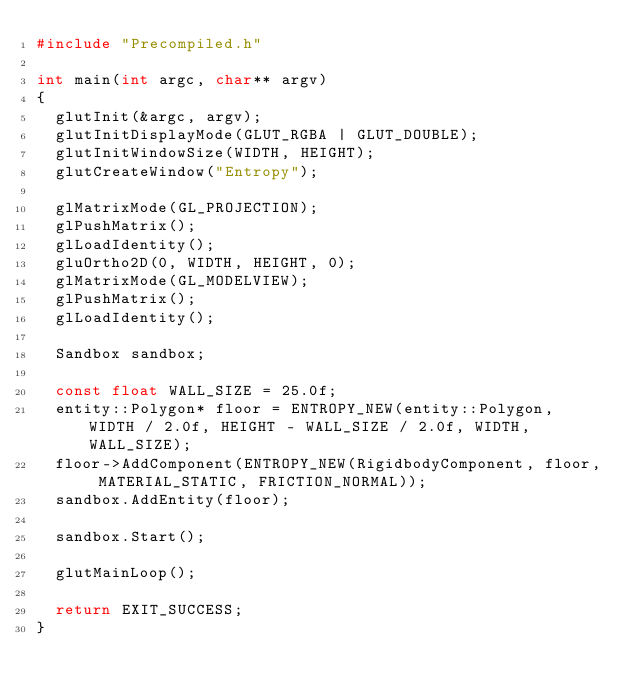Convert code to text. <code><loc_0><loc_0><loc_500><loc_500><_C++_>#include "Precompiled.h"

int main(int argc, char** argv)
{
	glutInit(&argc, argv);
	glutInitDisplayMode(GLUT_RGBA | GLUT_DOUBLE);
	glutInitWindowSize(WIDTH, HEIGHT);
	glutCreateWindow("Entropy");

	glMatrixMode(GL_PROJECTION);
	glPushMatrix();
	glLoadIdentity();
	gluOrtho2D(0, WIDTH, HEIGHT, 0);
	glMatrixMode(GL_MODELVIEW);
	glPushMatrix();
	glLoadIdentity();

	Sandbox sandbox;

	const float WALL_SIZE = 25.0f;
	entity::Polygon* floor = ENTROPY_NEW(entity::Polygon, WIDTH / 2.0f, HEIGHT - WALL_SIZE / 2.0f, WIDTH, WALL_SIZE);
	floor->AddComponent(ENTROPY_NEW(RigidbodyComponent, floor, MATERIAL_STATIC, FRICTION_NORMAL));
	sandbox.AddEntity(floor);

	sandbox.Start();

	glutMainLoop();

	return EXIT_SUCCESS;
}
</code> 